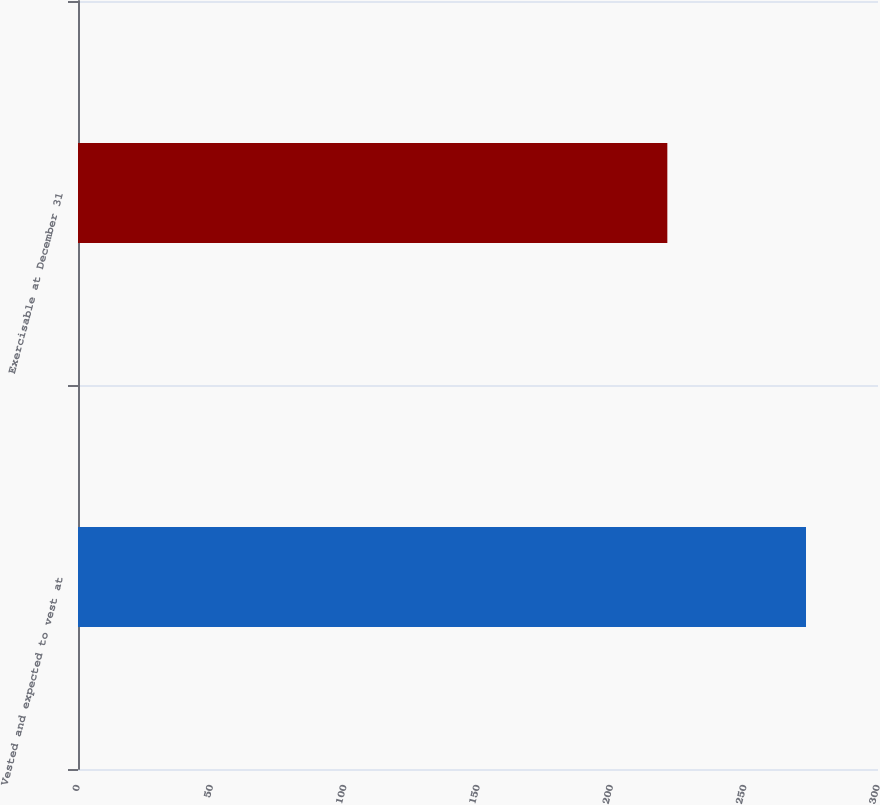<chart> <loc_0><loc_0><loc_500><loc_500><bar_chart><fcel>Vested and expected to vest at<fcel>Exercisable at December 31<nl><fcel>273<fcel>221<nl></chart> 